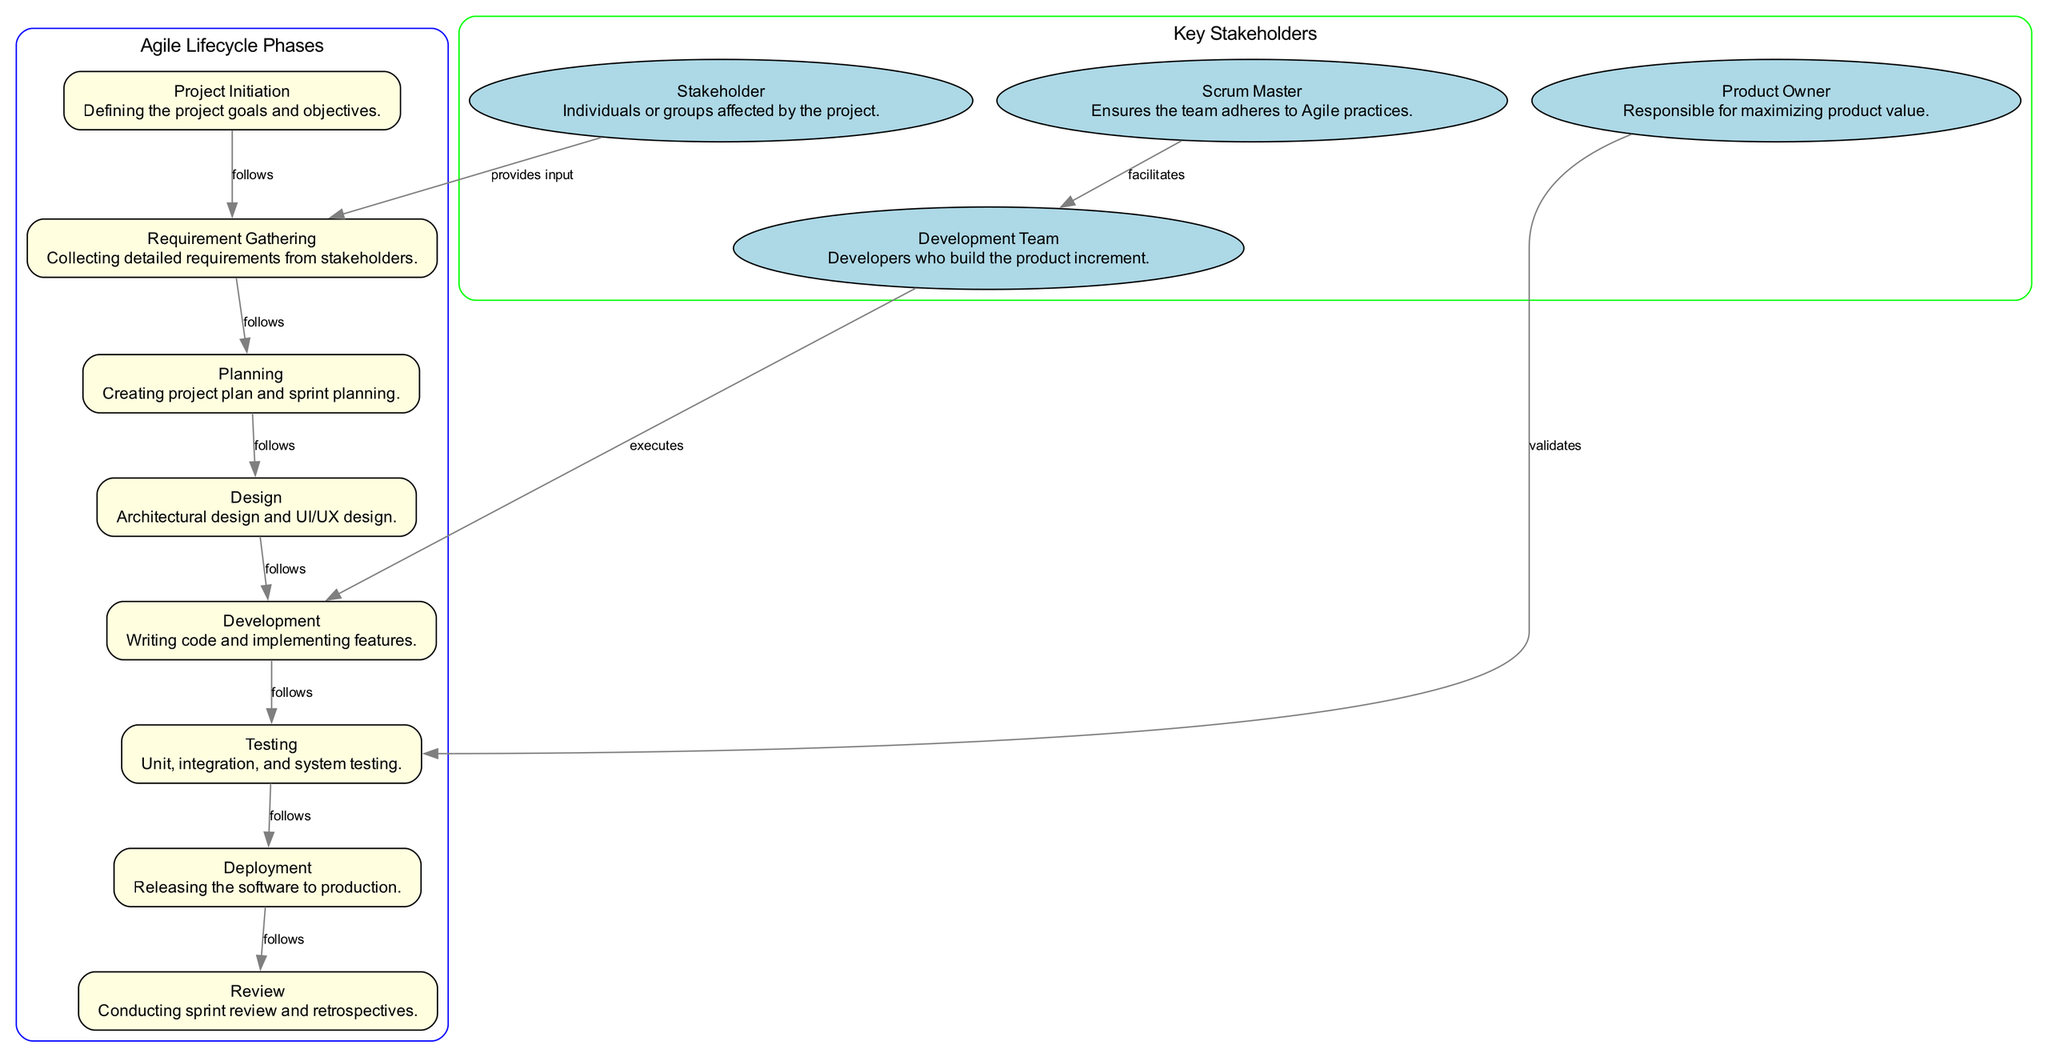What is the first phase of the Agile software development lifecycle? The first phase is indicated as "Project Initiation," which shows the project's initial goal-setting process.
Answer: Project Initiation How many key stakeholders are represented in the diagram? The diagram features four key stakeholders: Stakeholder, Product Owner, Scrum Master, and Development Team. This can be counted from the nodes labeled from 9 to 12.
Answer: Four What follows the "Testing" phase? The diagram shows the flow from "Testing" directly to "Deployment," indicating that this phase comes next.
Answer: Deployment Who validates the outcomes during the Testing phase? According to the diagram, the "Product Owner" validates during the "Testing" phase, as shown by the edge connecting these two nodes.
Answer: Product Owner Which node describes the creating of the project plan? The "Planning" node describes the creation of the project plan, as noted in its description.
Answer: Planning What is the relationship between the Development Team and the Development phase? The "Development Team" executes the "Development" phase, which shows the direct connection where the Development Team is tasked with this phase's activities.
Answer: Executes List the phases of the Agile lifecycle in order from initiation to review. The diagram highlights the flow of the phases as follows: Project Initiation, Requirement Gathering, Planning, Design, Development, Testing, Deployment, Review. This can be derived from the ordered nodes connected by edges.
Answer: Project Initiation, Requirement Gathering, Planning, Design, Development, Testing, Deployment, Review What color are the stakeholder nodes displayed in the diagram? The stakeholder nodes are colored light blue, as noted in the diagram's styling for those specific nodes.
Answer: Light blue How is the Scrum Master involved in the Agile process? The diagram indicates that the Scrum Master facilitates the Development Team's activities, demonstrating their role in supporting the Agile practices.
Answer: Facilitates 